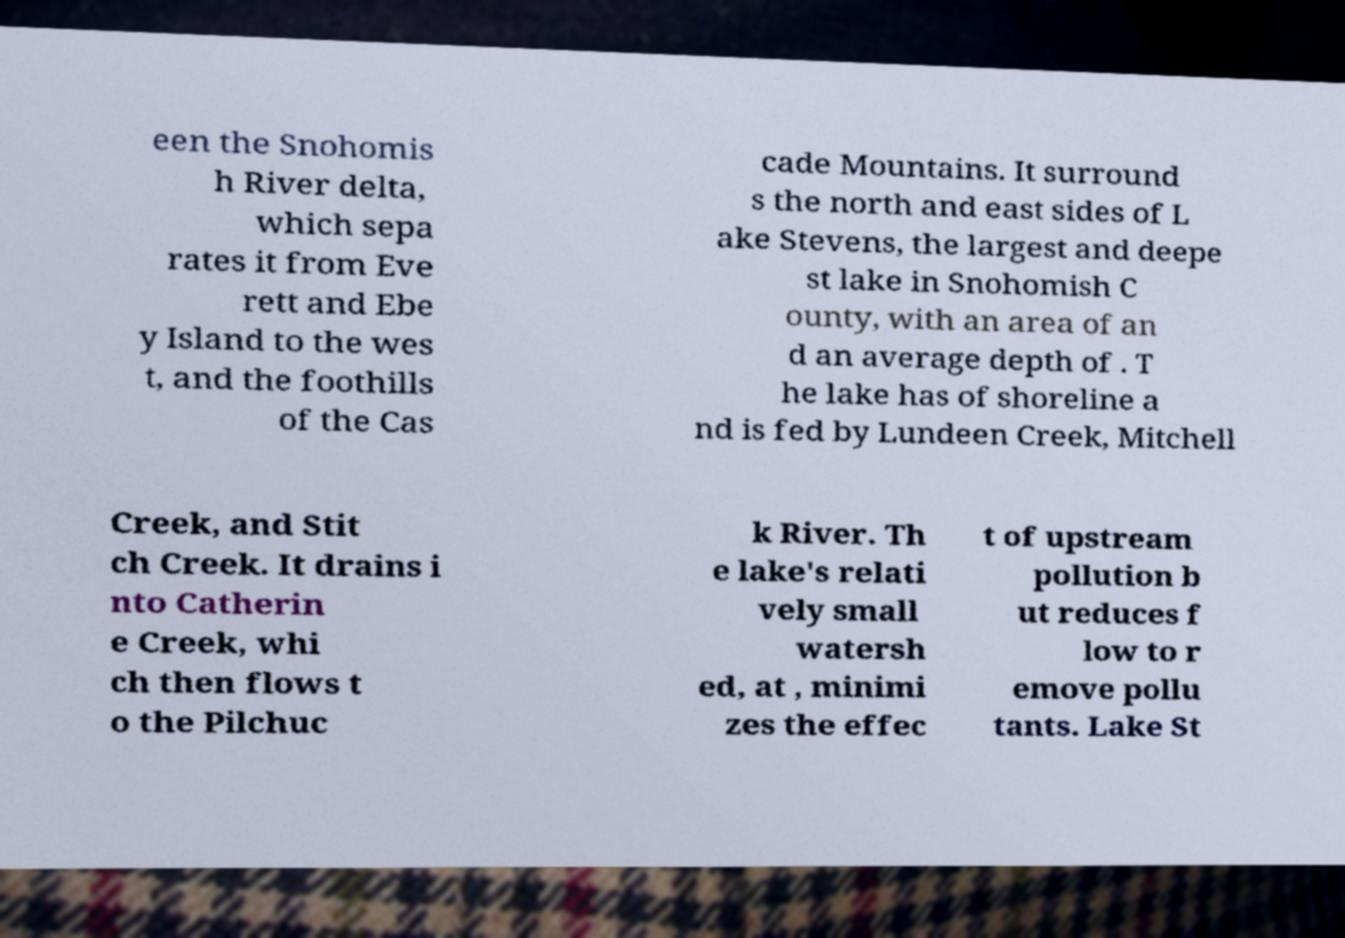There's text embedded in this image that I need extracted. Can you transcribe it verbatim? een the Snohomis h River delta, which sepa rates it from Eve rett and Ebe y Island to the wes t, and the foothills of the Cas cade Mountains. It surround s the north and east sides of L ake Stevens, the largest and deepe st lake in Snohomish C ounty, with an area of an d an average depth of . T he lake has of shoreline a nd is fed by Lundeen Creek, Mitchell Creek, and Stit ch Creek. It drains i nto Catherin e Creek, whi ch then flows t o the Pilchuc k River. Th e lake's relati vely small watersh ed, at , minimi zes the effec t of upstream pollution b ut reduces f low to r emove pollu tants. Lake St 